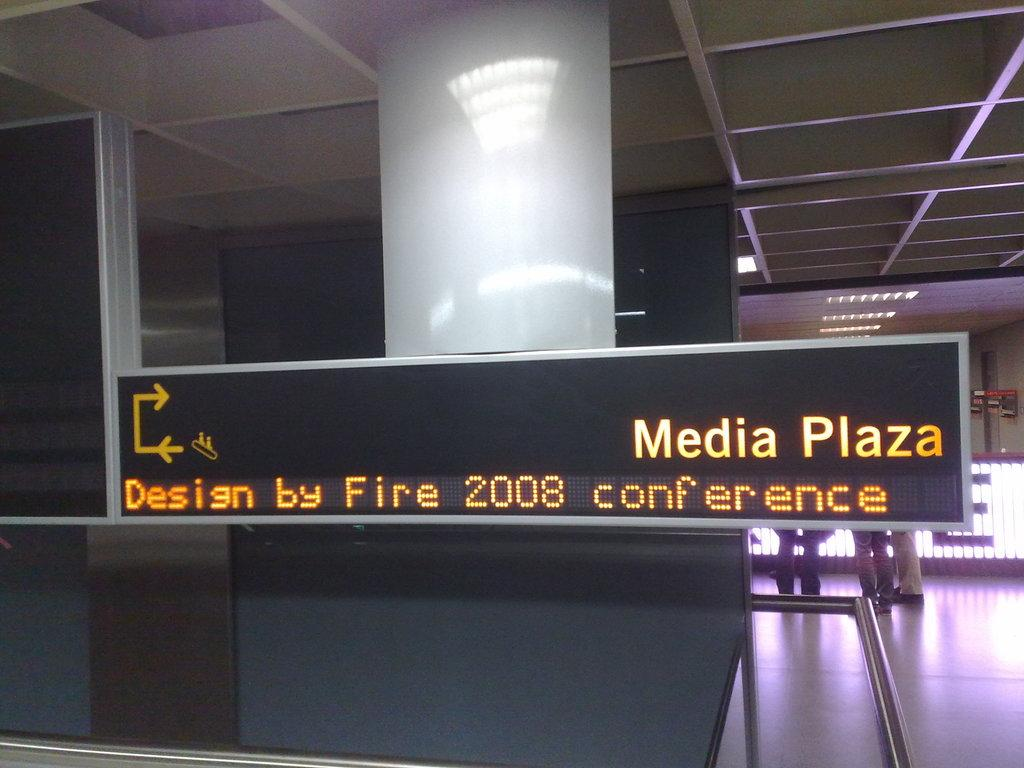<image>
Present a compact description of the photo's key features. A sign for Media Plaza and the Design by Fire 2008 conference 